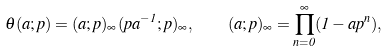Convert formula to latex. <formula><loc_0><loc_0><loc_500><loc_500>\theta ( a ; p ) = ( a ; p ) _ { \infty } ( p a ^ { - 1 } ; p ) _ { \infty } , \quad ( a ; p ) _ { \infty } = \prod _ { n = 0 } ^ { \infty } ( 1 - a p ^ { n } ) ,</formula> 